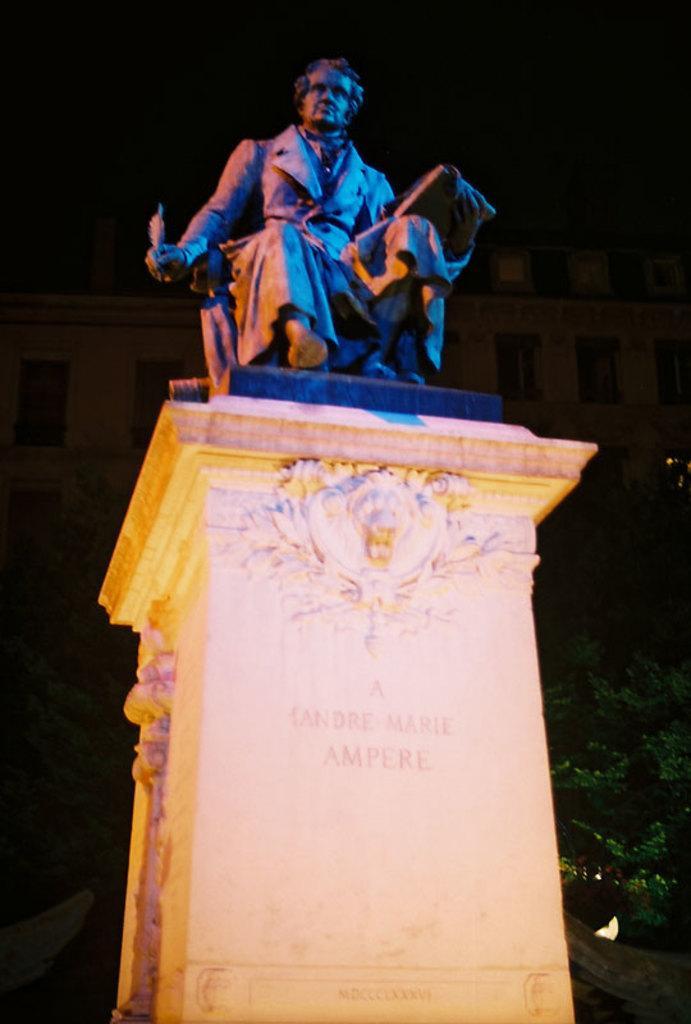Can you describe this image briefly? It is a statue of a person and the statue is placed on a tall wall. 